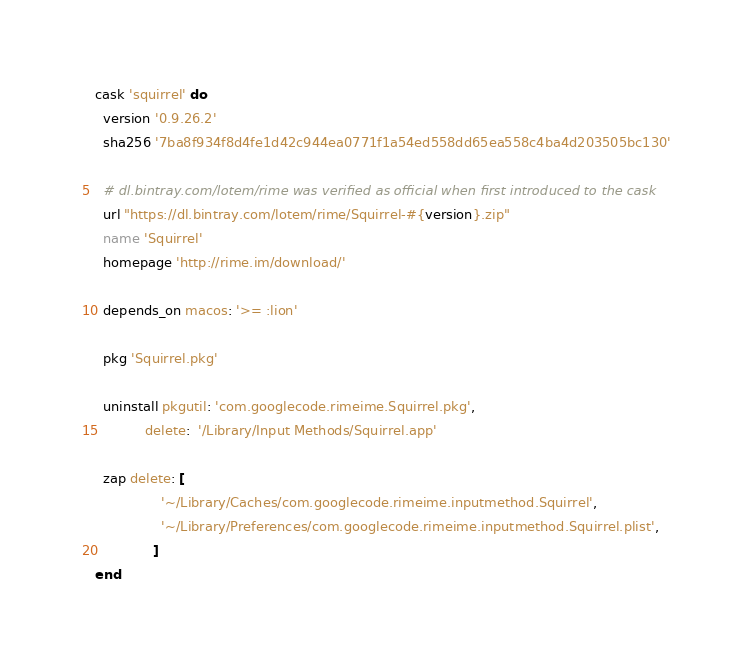Convert code to text. <code><loc_0><loc_0><loc_500><loc_500><_Ruby_>cask 'squirrel' do
  version '0.9.26.2'
  sha256 '7ba8f934f8d4fe1d42c944ea0771f1a54ed558dd65ea558c4ba4d203505bc130'

  # dl.bintray.com/lotem/rime was verified as official when first introduced to the cask
  url "https://dl.bintray.com/lotem/rime/Squirrel-#{version}.zip"
  name 'Squirrel'
  homepage 'http://rime.im/download/'

  depends_on macos: '>= :lion'

  pkg 'Squirrel.pkg'

  uninstall pkgutil: 'com.googlecode.rimeime.Squirrel.pkg',
            delete:  '/Library/Input Methods/Squirrel.app'

  zap delete: [
                '~/Library/Caches/com.googlecode.rimeime.inputmethod.Squirrel',
                '~/Library/Preferences/com.googlecode.rimeime.inputmethod.Squirrel.plist',
              ]
end
</code> 